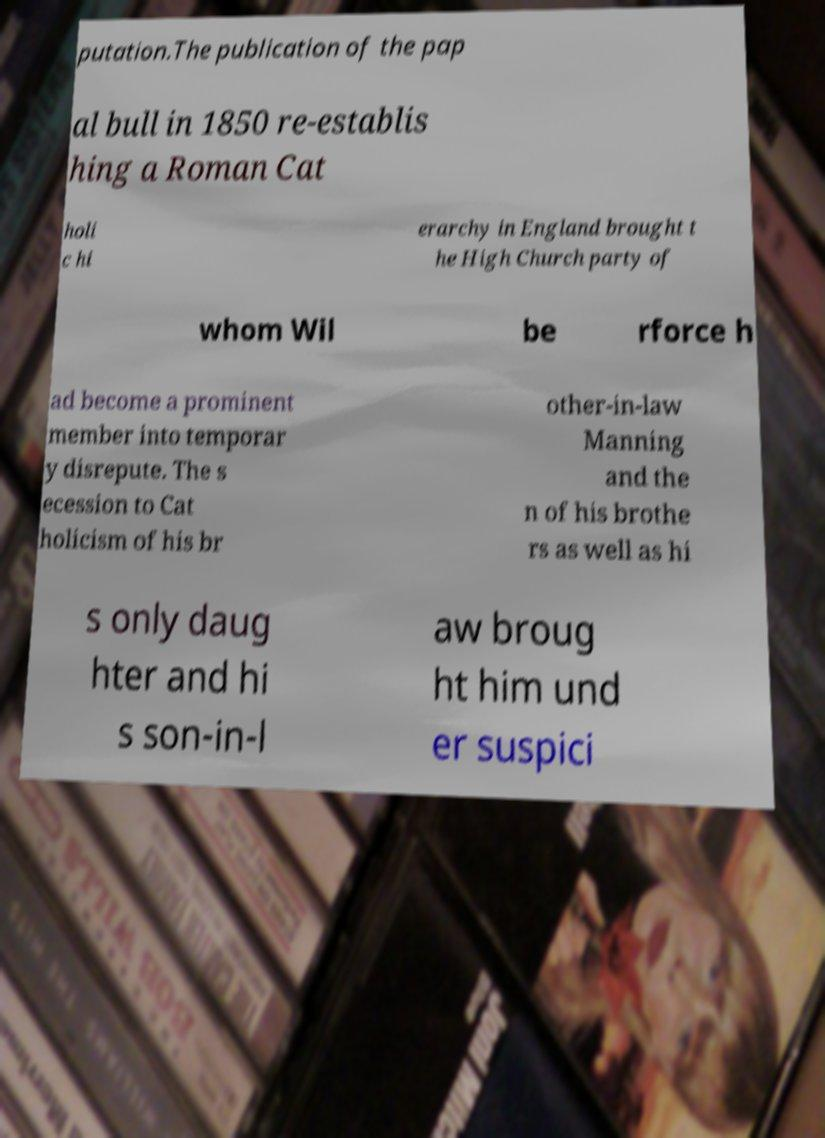There's text embedded in this image that I need extracted. Can you transcribe it verbatim? putation.The publication of the pap al bull in 1850 re-establis hing a Roman Cat holi c hi erarchy in England brought t he High Church party of whom Wil be rforce h ad become a prominent member into temporar y disrepute. The s ecession to Cat holicism of his br other-in-law Manning and the n of his brothe rs as well as hi s only daug hter and hi s son-in-l aw broug ht him und er suspici 